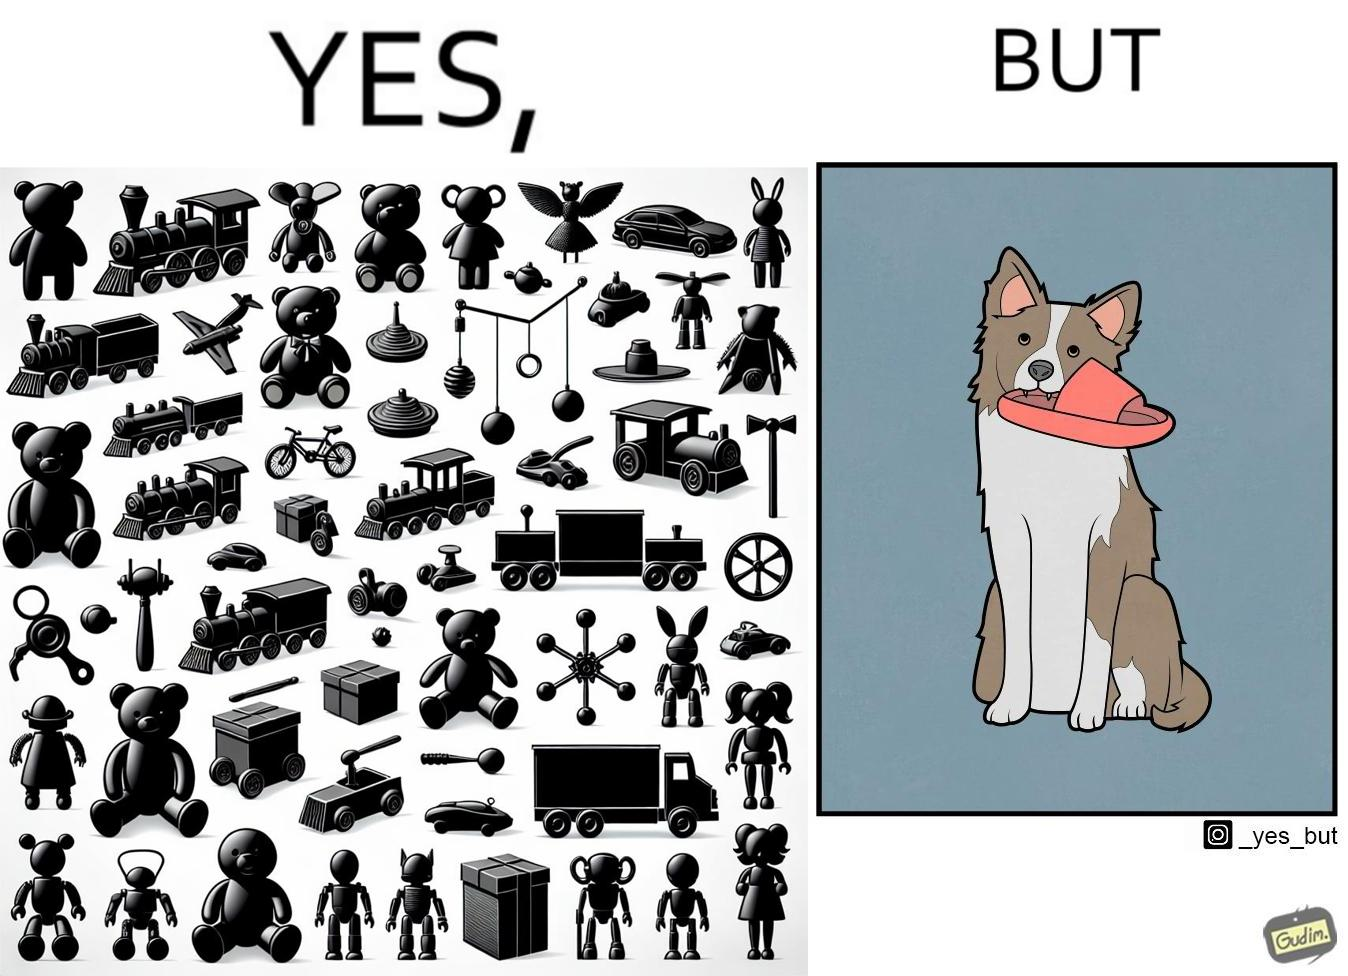Why is this image considered satirical? The image is ironical, as even though the dog owner has bought toys for the dog, the dog is playing with a slipper in its mouth. 